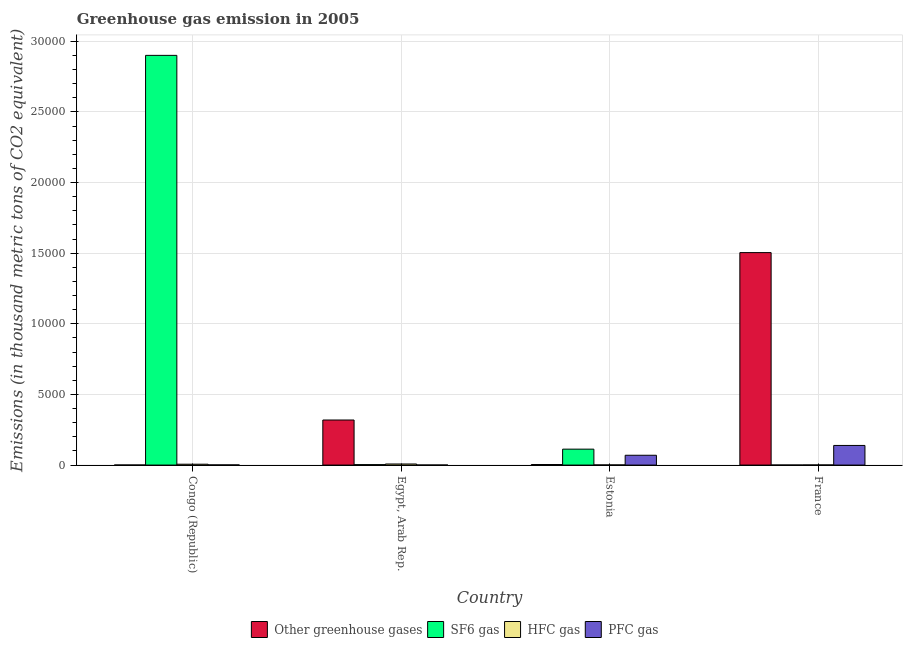How many different coloured bars are there?
Your answer should be compact. 4. How many groups of bars are there?
Your answer should be compact. 4. Are the number of bars on each tick of the X-axis equal?
Provide a short and direct response. Yes. What is the label of the 1st group of bars from the left?
Your answer should be very brief. Congo (Republic). In how many cases, is the number of bars for a given country not equal to the number of legend labels?
Make the answer very short. 0. What is the emission of sf6 gas in Congo (Republic)?
Your response must be concise. 2.90e+04. Across all countries, what is the maximum emission of pfc gas?
Your response must be concise. 1389.7. Across all countries, what is the minimum emission of greenhouse gases?
Your answer should be compact. 4.7. In which country was the emission of hfc gas minimum?
Ensure brevity in your answer.  France. What is the total emission of sf6 gas in the graph?
Make the answer very short. 3.02e+04. What is the difference between the emission of hfc gas in Congo (Republic) and that in Egypt, Arab Rep.?
Offer a terse response. -14.9. What is the difference between the emission of hfc gas in Congo (Republic) and the emission of greenhouse gases in France?
Ensure brevity in your answer.  -1.50e+04. What is the average emission of greenhouse gases per country?
Provide a short and direct response. 4568.28. What is the difference between the emission of greenhouse gases and emission of pfc gas in France?
Provide a succinct answer. 1.36e+04. What is the ratio of the emission of greenhouse gases in Congo (Republic) to that in Egypt, Arab Rep.?
Provide a succinct answer. 0. Is the emission of hfc gas in Egypt, Arab Rep. less than that in France?
Your answer should be very brief. No. Is the difference between the emission of pfc gas in Congo (Republic) and Egypt, Arab Rep. greater than the difference between the emission of sf6 gas in Congo (Republic) and Egypt, Arab Rep.?
Make the answer very short. No. What is the difference between the highest and the second highest emission of pfc gas?
Provide a succinct answer. 694.6. What is the difference between the highest and the lowest emission of pfc gas?
Provide a short and direct response. 1386.3. What does the 2nd bar from the left in Estonia represents?
Offer a terse response. SF6 gas. What does the 1st bar from the right in Estonia represents?
Offer a very short reply. PFC gas. Are all the bars in the graph horizontal?
Make the answer very short. No. How many countries are there in the graph?
Give a very brief answer. 4. What is the difference between two consecutive major ticks on the Y-axis?
Ensure brevity in your answer.  5000. Are the values on the major ticks of Y-axis written in scientific E-notation?
Give a very brief answer. No. How many legend labels are there?
Your answer should be very brief. 4. How are the legend labels stacked?
Keep it short and to the point. Horizontal. What is the title of the graph?
Your answer should be very brief. Greenhouse gas emission in 2005. Does "Primary education" appear as one of the legend labels in the graph?
Offer a very short reply. No. What is the label or title of the X-axis?
Keep it short and to the point. Country. What is the label or title of the Y-axis?
Provide a short and direct response. Emissions (in thousand metric tons of CO2 equivalent). What is the Emissions (in thousand metric tons of CO2 equivalent) in SF6 gas in Congo (Republic)?
Offer a terse response. 2.90e+04. What is the Emissions (in thousand metric tons of CO2 equivalent) in HFC gas in Congo (Republic)?
Your answer should be compact. 61.5. What is the Emissions (in thousand metric tons of CO2 equivalent) in PFC gas in Congo (Republic)?
Give a very brief answer. 10.9. What is the Emissions (in thousand metric tons of CO2 equivalent) of Other greenhouse gases in Egypt, Arab Rep.?
Your response must be concise. 3189.8. What is the Emissions (in thousand metric tons of CO2 equivalent) of SF6 gas in Egypt, Arab Rep.?
Provide a succinct answer. 31.5. What is the Emissions (in thousand metric tons of CO2 equivalent) in HFC gas in Egypt, Arab Rep.?
Provide a succinct answer. 76.4. What is the Emissions (in thousand metric tons of CO2 equivalent) in PFC gas in Egypt, Arab Rep.?
Provide a succinct answer. 3.4. What is the Emissions (in thousand metric tons of CO2 equivalent) in Other greenhouse gases in Estonia?
Ensure brevity in your answer.  39.4. What is the Emissions (in thousand metric tons of CO2 equivalent) of SF6 gas in Estonia?
Provide a succinct answer. 1127.3. What is the Emissions (in thousand metric tons of CO2 equivalent) in PFC gas in Estonia?
Offer a terse response. 695.1. What is the Emissions (in thousand metric tons of CO2 equivalent) in Other greenhouse gases in France?
Your response must be concise. 1.50e+04. What is the Emissions (in thousand metric tons of CO2 equivalent) in PFC gas in France?
Your answer should be very brief. 1389.7. Across all countries, what is the maximum Emissions (in thousand metric tons of CO2 equivalent) of Other greenhouse gases?
Give a very brief answer. 1.50e+04. Across all countries, what is the maximum Emissions (in thousand metric tons of CO2 equivalent) in SF6 gas?
Keep it short and to the point. 2.90e+04. Across all countries, what is the maximum Emissions (in thousand metric tons of CO2 equivalent) in HFC gas?
Offer a terse response. 76.4. Across all countries, what is the maximum Emissions (in thousand metric tons of CO2 equivalent) of PFC gas?
Give a very brief answer. 1389.7. Across all countries, what is the minimum Emissions (in thousand metric tons of CO2 equivalent) of Other greenhouse gases?
Your response must be concise. 4.7. Across all countries, what is the minimum Emissions (in thousand metric tons of CO2 equivalent) in SF6 gas?
Provide a succinct answer. 2.2. What is the total Emissions (in thousand metric tons of CO2 equivalent) in Other greenhouse gases in the graph?
Keep it short and to the point. 1.83e+04. What is the total Emissions (in thousand metric tons of CO2 equivalent) of SF6 gas in the graph?
Offer a very short reply. 3.02e+04. What is the total Emissions (in thousand metric tons of CO2 equivalent) in HFC gas in the graph?
Your answer should be compact. 156.6. What is the total Emissions (in thousand metric tons of CO2 equivalent) of PFC gas in the graph?
Ensure brevity in your answer.  2099.1. What is the difference between the Emissions (in thousand metric tons of CO2 equivalent) of Other greenhouse gases in Congo (Republic) and that in Egypt, Arab Rep.?
Keep it short and to the point. -3185.1. What is the difference between the Emissions (in thousand metric tons of CO2 equivalent) of SF6 gas in Congo (Republic) and that in Egypt, Arab Rep.?
Keep it short and to the point. 2.90e+04. What is the difference between the Emissions (in thousand metric tons of CO2 equivalent) in HFC gas in Congo (Republic) and that in Egypt, Arab Rep.?
Your answer should be compact. -14.9. What is the difference between the Emissions (in thousand metric tons of CO2 equivalent) of PFC gas in Congo (Republic) and that in Egypt, Arab Rep.?
Provide a short and direct response. 7.5. What is the difference between the Emissions (in thousand metric tons of CO2 equivalent) in Other greenhouse gases in Congo (Republic) and that in Estonia?
Your answer should be very brief. -34.7. What is the difference between the Emissions (in thousand metric tons of CO2 equivalent) in SF6 gas in Congo (Republic) and that in Estonia?
Keep it short and to the point. 2.79e+04. What is the difference between the Emissions (in thousand metric tons of CO2 equivalent) in HFC gas in Congo (Republic) and that in Estonia?
Your answer should be very brief. 51.2. What is the difference between the Emissions (in thousand metric tons of CO2 equivalent) in PFC gas in Congo (Republic) and that in Estonia?
Your answer should be very brief. -684.2. What is the difference between the Emissions (in thousand metric tons of CO2 equivalent) in Other greenhouse gases in Congo (Republic) and that in France?
Your answer should be compact. -1.50e+04. What is the difference between the Emissions (in thousand metric tons of CO2 equivalent) of SF6 gas in Congo (Republic) and that in France?
Ensure brevity in your answer.  2.90e+04. What is the difference between the Emissions (in thousand metric tons of CO2 equivalent) of HFC gas in Congo (Republic) and that in France?
Make the answer very short. 53.1. What is the difference between the Emissions (in thousand metric tons of CO2 equivalent) in PFC gas in Congo (Republic) and that in France?
Your answer should be very brief. -1378.8. What is the difference between the Emissions (in thousand metric tons of CO2 equivalent) of Other greenhouse gases in Egypt, Arab Rep. and that in Estonia?
Provide a short and direct response. 3150.4. What is the difference between the Emissions (in thousand metric tons of CO2 equivalent) of SF6 gas in Egypt, Arab Rep. and that in Estonia?
Your answer should be compact. -1095.8. What is the difference between the Emissions (in thousand metric tons of CO2 equivalent) of HFC gas in Egypt, Arab Rep. and that in Estonia?
Offer a terse response. 66.1. What is the difference between the Emissions (in thousand metric tons of CO2 equivalent) of PFC gas in Egypt, Arab Rep. and that in Estonia?
Keep it short and to the point. -691.7. What is the difference between the Emissions (in thousand metric tons of CO2 equivalent) in Other greenhouse gases in Egypt, Arab Rep. and that in France?
Your response must be concise. -1.18e+04. What is the difference between the Emissions (in thousand metric tons of CO2 equivalent) of SF6 gas in Egypt, Arab Rep. and that in France?
Ensure brevity in your answer.  29.3. What is the difference between the Emissions (in thousand metric tons of CO2 equivalent) of HFC gas in Egypt, Arab Rep. and that in France?
Give a very brief answer. 68. What is the difference between the Emissions (in thousand metric tons of CO2 equivalent) in PFC gas in Egypt, Arab Rep. and that in France?
Give a very brief answer. -1386.3. What is the difference between the Emissions (in thousand metric tons of CO2 equivalent) in Other greenhouse gases in Estonia and that in France?
Make the answer very short. -1.50e+04. What is the difference between the Emissions (in thousand metric tons of CO2 equivalent) of SF6 gas in Estonia and that in France?
Your answer should be compact. 1125.1. What is the difference between the Emissions (in thousand metric tons of CO2 equivalent) in HFC gas in Estonia and that in France?
Provide a short and direct response. 1.9. What is the difference between the Emissions (in thousand metric tons of CO2 equivalent) of PFC gas in Estonia and that in France?
Ensure brevity in your answer.  -694.6. What is the difference between the Emissions (in thousand metric tons of CO2 equivalent) of Other greenhouse gases in Congo (Republic) and the Emissions (in thousand metric tons of CO2 equivalent) of SF6 gas in Egypt, Arab Rep.?
Provide a short and direct response. -26.8. What is the difference between the Emissions (in thousand metric tons of CO2 equivalent) of Other greenhouse gases in Congo (Republic) and the Emissions (in thousand metric tons of CO2 equivalent) of HFC gas in Egypt, Arab Rep.?
Offer a terse response. -71.7. What is the difference between the Emissions (in thousand metric tons of CO2 equivalent) in SF6 gas in Congo (Republic) and the Emissions (in thousand metric tons of CO2 equivalent) in HFC gas in Egypt, Arab Rep.?
Ensure brevity in your answer.  2.89e+04. What is the difference between the Emissions (in thousand metric tons of CO2 equivalent) in SF6 gas in Congo (Republic) and the Emissions (in thousand metric tons of CO2 equivalent) in PFC gas in Egypt, Arab Rep.?
Provide a short and direct response. 2.90e+04. What is the difference between the Emissions (in thousand metric tons of CO2 equivalent) in HFC gas in Congo (Republic) and the Emissions (in thousand metric tons of CO2 equivalent) in PFC gas in Egypt, Arab Rep.?
Offer a very short reply. 58.1. What is the difference between the Emissions (in thousand metric tons of CO2 equivalent) of Other greenhouse gases in Congo (Republic) and the Emissions (in thousand metric tons of CO2 equivalent) of SF6 gas in Estonia?
Offer a very short reply. -1122.6. What is the difference between the Emissions (in thousand metric tons of CO2 equivalent) of Other greenhouse gases in Congo (Republic) and the Emissions (in thousand metric tons of CO2 equivalent) of HFC gas in Estonia?
Keep it short and to the point. -5.6. What is the difference between the Emissions (in thousand metric tons of CO2 equivalent) of Other greenhouse gases in Congo (Republic) and the Emissions (in thousand metric tons of CO2 equivalent) of PFC gas in Estonia?
Give a very brief answer. -690.4. What is the difference between the Emissions (in thousand metric tons of CO2 equivalent) in SF6 gas in Congo (Republic) and the Emissions (in thousand metric tons of CO2 equivalent) in HFC gas in Estonia?
Offer a very short reply. 2.90e+04. What is the difference between the Emissions (in thousand metric tons of CO2 equivalent) in SF6 gas in Congo (Republic) and the Emissions (in thousand metric tons of CO2 equivalent) in PFC gas in Estonia?
Make the answer very short. 2.83e+04. What is the difference between the Emissions (in thousand metric tons of CO2 equivalent) of HFC gas in Congo (Republic) and the Emissions (in thousand metric tons of CO2 equivalent) of PFC gas in Estonia?
Keep it short and to the point. -633.6. What is the difference between the Emissions (in thousand metric tons of CO2 equivalent) in Other greenhouse gases in Congo (Republic) and the Emissions (in thousand metric tons of CO2 equivalent) in PFC gas in France?
Make the answer very short. -1385. What is the difference between the Emissions (in thousand metric tons of CO2 equivalent) of SF6 gas in Congo (Republic) and the Emissions (in thousand metric tons of CO2 equivalent) of HFC gas in France?
Make the answer very short. 2.90e+04. What is the difference between the Emissions (in thousand metric tons of CO2 equivalent) in SF6 gas in Congo (Republic) and the Emissions (in thousand metric tons of CO2 equivalent) in PFC gas in France?
Your answer should be compact. 2.76e+04. What is the difference between the Emissions (in thousand metric tons of CO2 equivalent) in HFC gas in Congo (Republic) and the Emissions (in thousand metric tons of CO2 equivalent) in PFC gas in France?
Offer a terse response. -1328.2. What is the difference between the Emissions (in thousand metric tons of CO2 equivalent) in Other greenhouse gases in Egypt, Arab Rep. and the Emissions (in thousand metric tons of CO2 equivalent) in SF6 gas in Estonia?
Your answer should be compact. 2062.5. What is the difference between the Emissions (in thousand metric tons of CO2 equivalent) in Other greenhouse gases in Egypt, Arab Rep. and the Emissions (in thousand metric tons of CO2 equivalent) in HFC gas in Estonia?
Your answer should be very brief. 3179.5. What is the difference between the Emissions (in thousand metric tons of CO2 equivalent) in Other greenhouse gases in Egypt, Arab Rep. and the Emissions (in thousand metric tons of CO2 equivalent) in PFC gas in Estonia?
Your answer should be compact. 2494.7. What is the difference between the Emissions (in thousand metric tons of CO2 equivalent) of SF6 gas in Egypt, Arab Rep. and the Emissions (in thousand metric tons of CO2 equivalent) of HFC gas in Estonia?
Your answer should be compact. 21.2. What is the difference between the Emissions (in thousand metric tons of CO2 equivalent) in SF6 gas in Egypt, Arab Rep. and the Emissions (in thousand metric tons of CO2 equivalent) in PFC gas in Estonia?
Make the answer very short. -663.6. What is the difference between the Emissions (in thousand metric tons of CO2 equivalent) in HFC gas in Egypt, Arab Rep. and the Emissions (in thousand metric tons of CO2 equivalent) in PFC gas in Estonia?
Provide a short and direct response. -618.7. What is the difference between the Emissions (in thousand metric tons of CO2 equivalent) in Other greenhouse gases in Egypt, Arab Rep. and the Emissions (in thousand metric tons of CO2 equivalent) in SF6 gas in France?
Your response must be concise. 3187.6. What is the difference between the Emissions (in thousand metric tons of CO2 equivalent) of Other greenhouse gases in Egypt, Arab Rep. and the Emissions (in thousand metric tons of CO2 equivalent) of HFC gas in France?
Offer a very short reply. 3181.4. What is the difference between the Emissions (in thousand metric tons of CO2 equivalent) in Other greenhouse gases in Egypt, Arab Rep. and the Emissions (in thousand metric tons of CO2 equivalent) in PFC gas in France?
Ensure brevity in your answer.  1800.1. What is the difference between the Emissions (in thousand metric tons of CO2 equivalent) in SF6 gas in Egypt, Arab Rep. and the Emissions (in thousand metric tons of CO2 equivalent) in HFC gas in France?
Provide a short and direct response. 23.1. What is the difference between the Emissions (in thousand metric tons of CO2 equivalent) of SF6 gas in Egypt, Arab Rep. and the Emissions (in thousand metric tons of CO2 equivalent) of PFC gas in France?
Provide a succinct answer. -1358.2. What is the difference between the Emissions (in thousand metric tons of CO2 equivalent) of HFC gas in Egypt, Arab Rep. and the Emissions (in thousand metric tons of CO2 equivalent) of PFC gas in France?
Provide a succinct answer. -1313.3. What is the difference between the Emissions (in thousand metric tons of CO2 equivalent) of Other greenhouse gases in Estonia and the Emissions (in thousand metric tons of CO2 equivalent) of SF6 gas in France?
Your answer should be very brief. 37.2. What is the difference between the Emissions (in thousand metric tons of CO2 equivalent) of Other greenhouse gases in Estonia and the Emissions (in thousand metric tons of CO2 equivalent) of PFC gas in France?
Your answer should be very brief. -1350.3. What is the difference between the Emissions (in thousand metric tons of CO2 equivalent) of SF6 gas in Estonia and the Emissions (in thousand metric tons of CO2 equivalent) of HFC gas in France?
Ensure brevity in your answer.  1118.9. What is the difference between the Emissions (in thousand metric tons of CO2 equivalent) in SF6 gas in Estonia and the Emissions (in thousand metric tons of CO2 equivalent) in PFC gas in France?
Make the answer very short. -262.4. What is the difference between the Emissions (in thousand metric tons of CO2 equivalent) in HFC gas in Estonia and the Emissions (in thousand metric tons of CO2 equivalent) in PFC gas in France?
Offer a very short reply. -1379.4. What is the average Emissions (in thousand metric tons of CO2 equivalent) in Other greenhouse gases per country?
Give a very brief answer. 4568.27. What is the average Emissions (in thousand metric tons of CO2 equivalent) of SF6 gas per country?
Your response must be concise. 7540.43. What is the average Emissions (in thousand metric tons of CO2 equivalent) of HFC gas per country?
Give a very brief answer. 39.15. What is the average Emissions (in thousand metric tons of CO2 equivalent) of PFC gas per country?
Offer a terse response. 524.77. What is the difference between the Emissions (in thousand metric tons of CO2 equivalent) of Other greenhouse gases and Emissions (in thousand metric tons of CO2 equivalent) of SF6 gas in Congo (Republic)?
Offer a terse response. -2.90e+04. What is the difference between the Emissions (in thousand metric tons of CO2 equivalent) in Other greenhouse gases and Emissions (in thousand metric tons of CO2 equivalent) in HFC gas in Congo (Republic)?
Your answer should be very brief. -56.8. What is the difference between the Emissions (in thousand metric tons of CO2 equivalent) of Other greenhouse gases and Emissions (in thousand metric tons of CO2 equivalent) of PFC gas in Congo (Republic)?
Your response must be concise. -6.2. What is the difference between the Emissions (in thousand metric tons of CO2 equivalent) of SF6 gas and Emissions (in thousand metric tons of CO2 equivalent) of HFC gas in Congo (Republic)?
Offer a very short reply. 2.89e+04. What is the difference between the Emissions (in thousand metric tons of CO2 equivalent) of SF6 gas and Emissions (in thousand metric tons of CO2 equivalent) of PFC gas in Congo (Republic)?
Your answer should be compact. 2.90e+04. What is the difference between the Emissions (in thousand metric tons of CO2 equivalent) of HFC gas and Emissions (in thousand metric tons of CO2 equivalent) of PFC gas in Congo (Republic)?
Ensure brevity in your answer.  50.6. What is the difference between the Emissions (in thousand metric tons of CO2 equivalent) of Other greenhouse gases and Emissions (in thousand metric tons of CO2 equivalent) of SF6 gas in Egypt, Arab Rep.?
Offer a very short reply. 3158.3. What is the difference between the Emissions (in thousand metric tons of CO2 equivalent) of Other greenhouse gases and Emissions (in thousand metric tons of CO2 equivalent) of HFC gas in Egypt, Arab Rep.?
Keep it short and to the point. 3113.4. What is the difference between the Emissions (in thousand metric tons of CO2 equivalent) of Other greenhouse gases and Emissions (in thousand metric tons of CO2 equivalent) of PFC gas in Egypt, Arab Rep.?
Give a very brief answer. 3186.4. What is the difference between the Emissions (in thousand metric tons of CO2 equivalent) of SF6 gas and Emissions (in thousand metric tons of CO2 equivalent) of HFC gas in Egypt, Arab Rep.?
Ensure brevity in your answer.  -44.9. What is the difference between the Emissions (in thousand metric tons of CO2 equivalent) of SF6 gas and Emissions (in thousand metric tons of CO2 equivalent) of PFC gas in Egypt, Arab Rep.?
Offer a very short reply. 28.1. What is the difference between the Emissions (in thousand metric tons of CO2 equivalent) in Other greenhouse gases and Emissions (in thousand metric tons of CO2 equivalent) in SF6 gas in Estonia?
Ensure brevity in your answer.  -1087.9. What is the difference between the Emissions (in thousand metric tons of CO2 equivalent) of Other greenhouse gases and Emissions (in thousand metric tons of CO2 equivalent) of HFC gas in Estonia?
Offer a terse response. 29.1. What is the difference between the Emissions (in thousand metric tons of CO2 equivalent) in Other greenhouse gases and Emissions (in thousand metric tons of CO2 equivalent) in PFC gas in Estonia?
Offer a terse response. -655.7. What is the difference between the Emissions (in thousand metric tons of CO2 equivalent) in SF6 gas and Emissions (in thousand metric tons of CO2 equivalent) in HFC gas in Estonia?
Provide a short and direct response. 1117. What is the difference between the Emissions (in thousand metric tons of CO2 equivalent) in SF6 gas and Emissions (in thousand metric tons of CO2 equivalent) in PFC gas in Estonia?
Keep it short and to the point. 432.2. What is the difference between the Emissions (in thousand metric tons of CO2 equivalent) of HFC gas and Emissions (in thousand metric tons of CO2 equivalent) of PFC gas in Estonia?
Provide a succinct answer. -684.8. What is the difference between the Emissions (in thousand metric tons of CO2 equivalent) in Other greenhouse gases and Emissions (in thousand metric tons of CO2 equivalent) in SF6 gas in France?
Provide a short and direct response. 1.50e+04. What is the difference between the Emissions (in thousand metric tons of CO2 equivalent) of Other greenhouse gases and Emissions (in thousand metric tons of CO2 equivalent) of HFC gas in France?
Ensure brevity in your answer.  1.50e+04. What is the difference between the Emissions (in thousand metric tons of CO2 equivalent) in Other greenhouse gases and Emissions (in thousand metric tons of CO2 equivalent) in PFC gas in France?
Give a very brief answer. 1.36e+04. What is the difference between the Emissions (in thousand metric tons of CO2 equivalent) of SF6 gas and Emissions (in thousand metric tons of CO2 equivalent) of PFC gas in France?
Offer a terse response. -1387.5. What is the difference between the Emissions (in thousand metric tons of CO2 equivalent) in HFC gas and Emissions (in thousand metric tons of CO2 equivalent) in PFC gas in France?
Give a very brief answer. -1381.3. What is the ratio of the Emissions (in thousand metric tons of CO2 equivalent) in Other greenhouse gases in Congo (Republic) to that in Egypt, Arab Rep.?
Your answer should be compact. 0. What is the ratio of the Emissions (in thousand metric tons of CO2 equivalent) in SF6 gas in Congo (Republic) to that in Egypt, Arab Rep.?
Make the answer very short. 920.66. What is the ratio of the Emissions (in thousand metric tons of CO2 equivalent) in HFC gas in Congo (Republic) to that in Egypt, Arab Rep.?
Make the answer very short. 0.81. What is the ratio of the Emissions (in thousand metric tons of CO2 equivalent) of PFC gas in Congo (Republic) to that in Egypt, Arab Rep.?
Provide a short and direct response. 3.21. What is the ratio of the Emissions (in thousand metric tons of CO2 equivalent) of Other greenhouse gases in Congo (Republic) to that in Estonia?
Provide a short and direct response. 0.12. What is the ratio of the Emissions (in thousand metric tons of CO2 equivalent) in SF6 gas in Congo (Republic) to that in Estonia?
Provide a short and direct response. 25.73. What is the ratio of the Emissions (in thousand metric tons of CO2 equivalent) of HFC gas in Congo (Republic) to that in Estonia?
Your answer should be compact. 5.97. What is the ratio of the Emissions (in thousand metric tons of CO2 equivalent) in PFC gas in Congo (Republic) to that in Estonia?
Make the answer very short. 0.02. What is the ratio of the Emissions (in thousand metric tons of CO2 equivalent) in Other greenhouse gases in Congo (Republic) to that in France?
Offer a terse response. 0. What is the ratio of the Emissions (in thousand metric tons of CO2 equivalent) in SF6 gas in Congo (Republic) to that in France?
Offer a terse response. 1.32e+04. What is the ratio of the Emissions (in thousand metric tons of CO2 equivalent) of HFC gas in Congo (Republic) to that in France?
Make the answer very short. 7.32. What is the ratio of the Emissions (in thousand metric tons of CO2 equivalent) of PFC gas in Congo (Republic) to that in France?
Offer a terse response. 0.01. What is the ratio of the Emissions (in thousand metric tons of CO2 equivalent) of Other greenhouse gases in Egypt, Arab Rep. to that in Estonia?
Provide a short and direct response. 80.96. What is the ratio of the Emissions (in thousand metric tons of CO2 equivalent) in SF6 gas in Egypt, Arab Rep. to that in Estonia?
Your answer should be compact. 0.03. What is the ratio of the Emissions (in thousand metric tons of CO2 equivalent) of HFC gas in Egypt, Arab Rep. to that in Estonia?
Provide a short and direct response. 7.42. What is the ratio of the Emissions (in thousand metric tons of CO2 equivalent) of PFC gas in Egypt, Arab Rep. to that in Estonia?
Provide a short and direct response. 0. What is the ratio of the Emissions (in thousand metric tons of CO2 equivalent) in Other greenhouse gases in Egypt, Arab Rep. to that in France?
Your answer should be very brief. 0.21. What is the ratio of the Emissions (in thousand metric tons of CO2 equivalent) in SF6 gas in Egypt, Arab Rep. to that in France?
Give a very brief answer. 14.32. What is the ratio of the Emissions (in thousand metric tons of CO2 equivalent) of HFC gas in Egypt, Arab Rep. to that in France?
Give a very brief answer. 9.1. What is the ratio of the Emissions (in thousand metric tons of CO2 equivalent) of PFC gas in Egypt, Arab Rep. to that in France?
Offer a terse response. 0. What is the ratio of the Emissions (in thousand metric tons of CO2 equivalent) of Other greenhouse gases in Estonia to that in France?
Your answer should be very brief. 0. What is the ratio of the Emissions (in thousand metric tons of CO2 equivalent) in SF6 gas in Estonia to that in France?
Keep it short and to the point. 512.41. What is the ratio of the Emissions (in thousand metric tons of CO2 equivalent) in HFC gas in Estonia to that in France?
Keep it short and to the point. 1.23. What is the ratio of the Emissions (in thousand metric tons of CO2 equivalent) of PFC gas in Estonia to that in France?
Offer a very short reply. 0.5. What is the difference between the highest and the second highest Emissions (in thousand metric tons of CO2 equivalent) in Other greenhouse gases?
Your answer should be compact. 1.18e+04. What is the difference between the highest and the second highest Emissions (in thousand metric tons of CO2 equivalent) of SF6 gas?
Your answer should be very brief. 2.79e+04. What is the difference between the highest and the second highest Emissions (in thousand metric tons of CO2 equivalent) in PFC gas?
Make the answer very short. 694.6. What is the difference between the highest and the lowest Emissions (in thousand metric tons of CO2 equivalent) of Other greenhouse gases?
Give a very brief answer. 1.50e+04. What is the difference between the highest and the lowest Emissions (in thousand metric tons of CO2 equivalent) of SF6 gas?
Offer a very short reply. 2.90e+04. What is the difference between the highest and the lowest Emissions (in thousand metric tons of CO2 equivalent) of HFC gas?
Make the answer very short. 68. What is the difference between the highest and the lowest Emissions (in thousand metric tons of CO2 equivalent) of PFC gas?
Your answer should be very brief. 1386.3. 